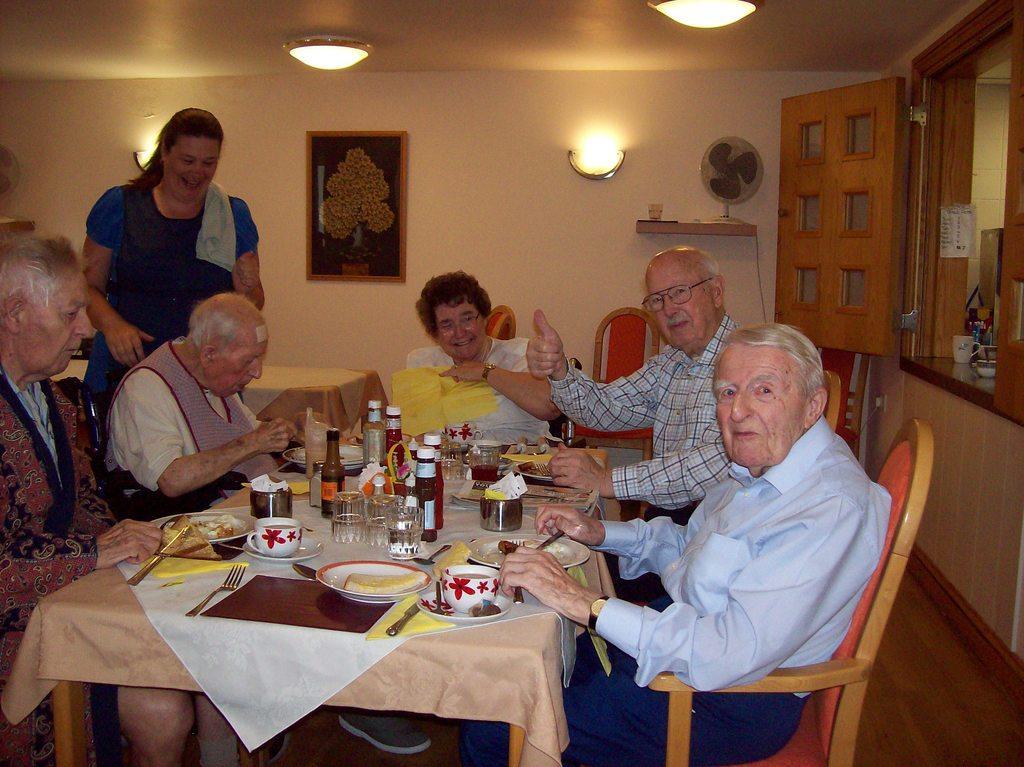Describe this image in one or two sentences. On the background we can see a wall and a frame over it. These are lights. This is a table fan on the desk. We can see a window her. Here we can see all the persons sitting on chairs infront of a table and on the table we can see table mats, spoons and forks, glasses, bottles and a plate of food. we can see one women ois standing here and she is hoilding a smile on her face. 